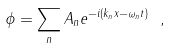<formula> <loc_0><loc_0><loc_500><loc_500>\phi = \sum _ { n } A _ { n } e ^ { - i ( k _ { n } x - \omega _ { n } t ) } \ ,</formula> 